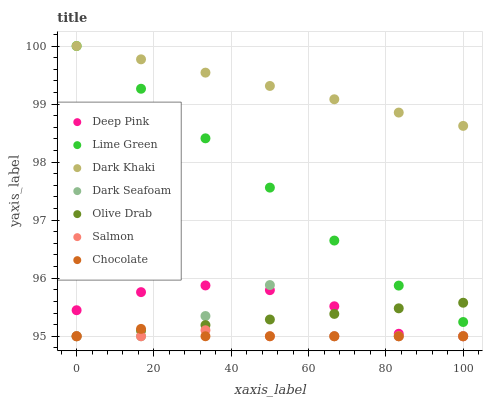Does Salmon have the minimum area under the curve?
Answer yes or no. Yes. Does Dark Khaki have the maximum area under the curve?
Answer yes or no. Yes. Does Chocolate have the minimum area under the curve?
Answer yes or no. No. Does Chocolate have the maximum area under the curve?
Answer yes or no. No. Is Dark Khaki the smoothest?
Answer yes or no. Yes. Is Dark Seafoam the roughest?
Answer yes or no. Yes. Is Salmon the smoothest?
Answer yes or no. No. Is Salmon the roughest?
Answer yes or no. No. Does Deep Pink have the lowest value?
Answer yes or no. Yes. Does Dark Khaki have the lowest value?
Answer yes or no. No. Does Lime Green have the highest value?
Answer yes or no. Yes. Does Chocolate have the highest value?
Answer yes or no. No. Is Olive Drab less than Dark Khaki?
Answer yes or no. Yes. Is Lime Green greater than Dark Seafoam?
Answer yes or no. Yes. Does Olive Drab intersect Chocolate?
Answer yes or no. Yes. Is Olive Drab less than Chocolate?
Answer yes or no. No. Is Olive Drab greater than Chocolate?
Answer yes or no. No. Does Olive Drab intersect Dark Khaki?
Answer yes or no. No. 